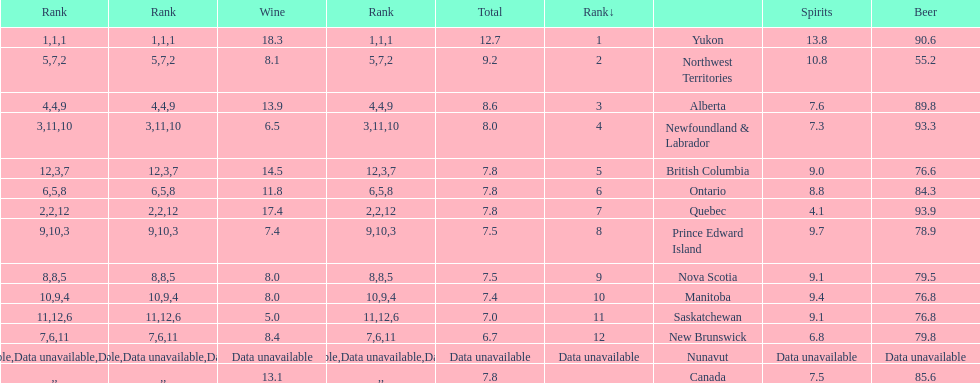Tell me province that drank more than 15 liters of wine. Yukon, Quebec. 